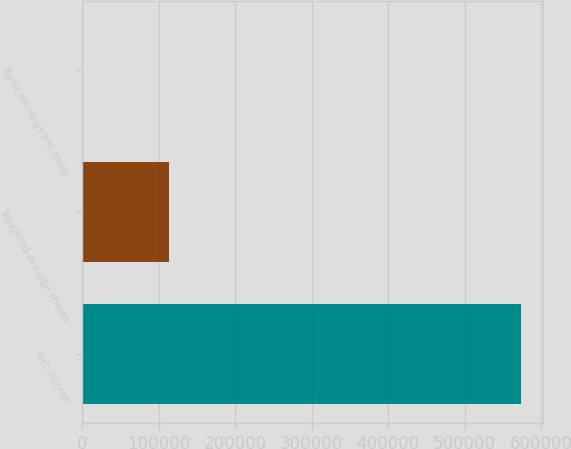Convert chart. <chart><loc_0><loc_0><loc_500><loc_500><bar_chart><fcel>Net income<fcel>Weighted-average shares<fcel>Basic earnings per share<nl><fcel>573942<fcel>113010<fcel>5.08<nl></chart> 